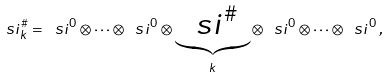<formula> <loc_0><loc_0><loc_500><loc_500>\ s i ^ { \# } _ { k } = \ s i ^ { 0 } \otimes \dots \otimes \ s i ^ { 0 } \otimes \underbrace { \ s i ^ { \# } } _ { k } \otimes \, \ s i ^ { 0 } \otimes \dots \otimes \ s i ^ { 0 } \, ,</formula> 